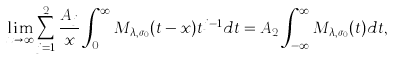Convert formula to latex. <formula><loc_0><loc_0><loc_500><loc_500>\lim _ { x \to \infty } \sum _ { j = 1 } ^ { 2 } \frac { A _ { j } } { x } \int _ { 0 } ^ { \infty } M _ { \lambda , \sigma _ { 0 } } ( t - x ) t ^ { j - 1 } d t = A _ { 2 } \int _ { - \infty } ^ { \infty } M _ { \lambda , \sigma _ { 0 } } ( t ) d t ,</formula> 